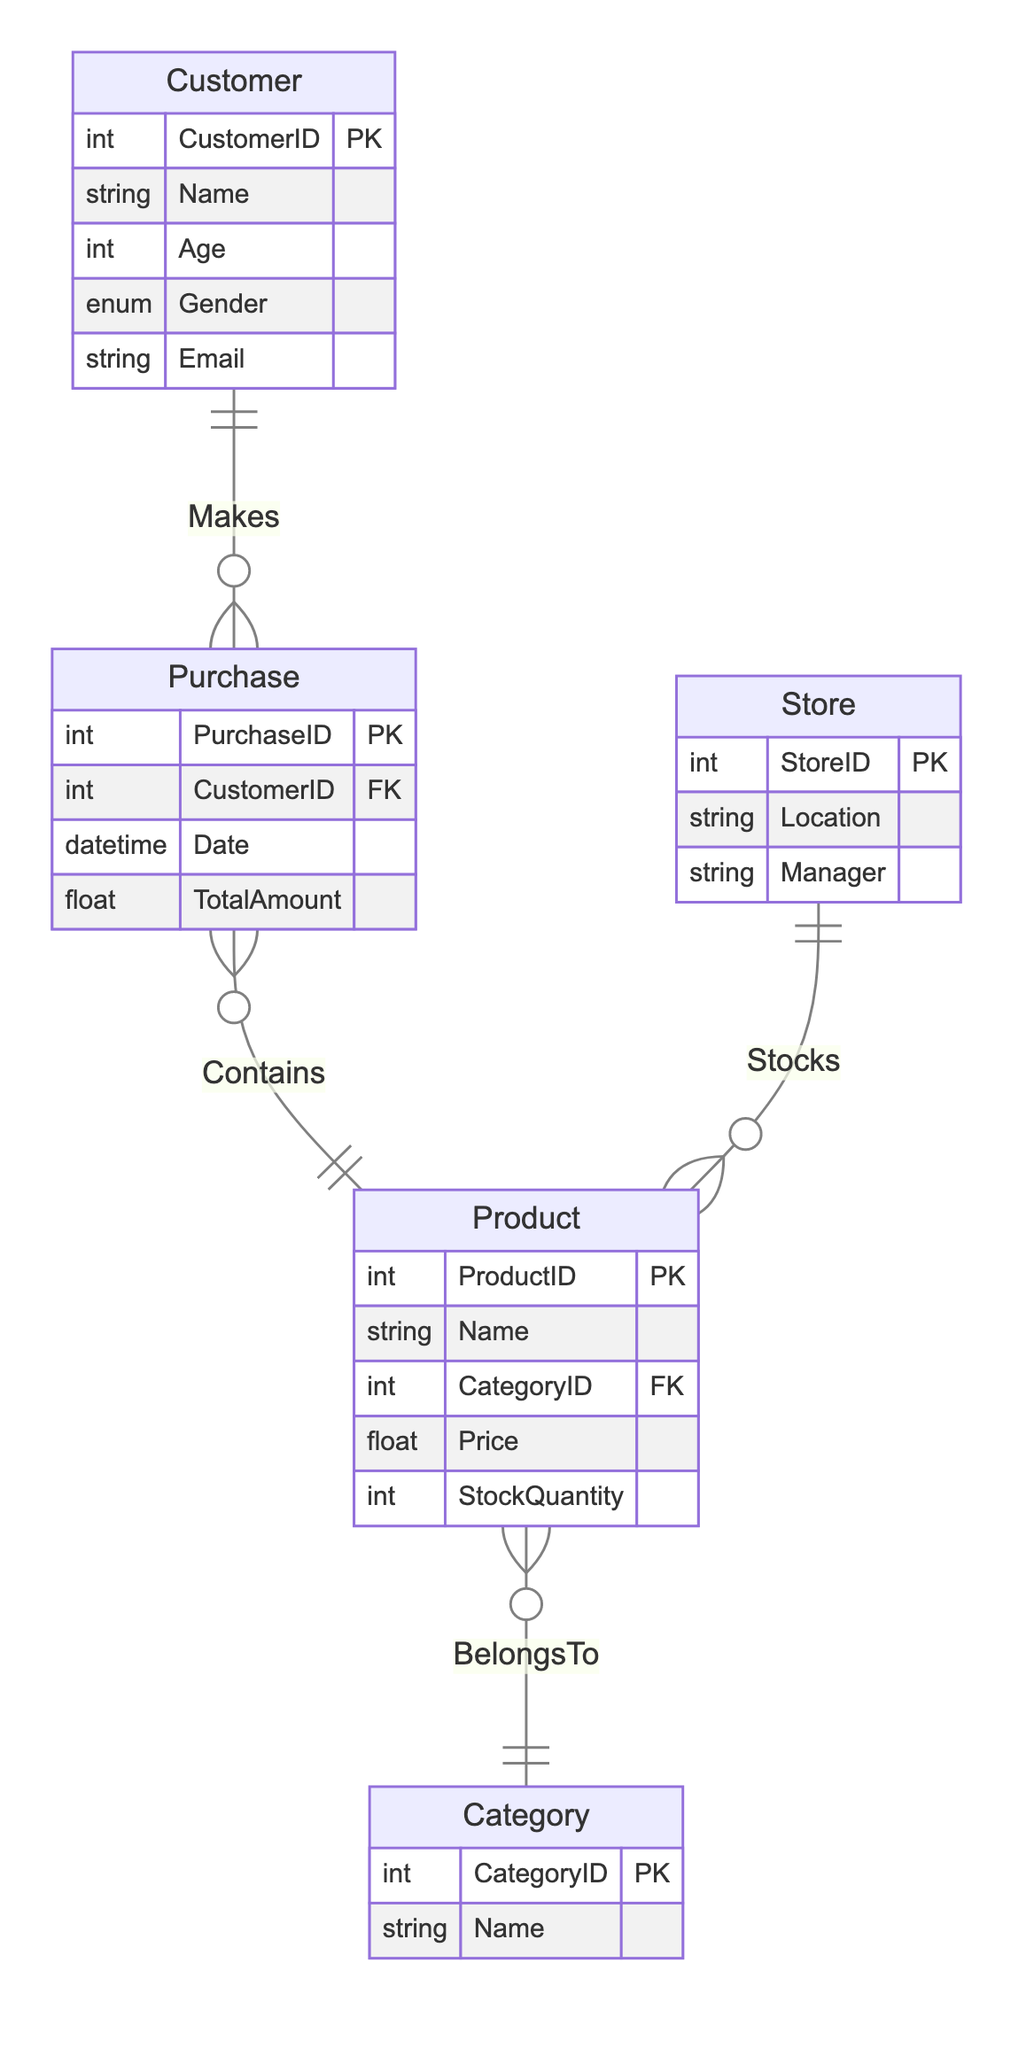What is the primary key for the Customer entity? The primary key for the Customer entity is identified in the diagram next to its attributes. It is labeled "CustomerID".
Answer: CustomerID How many total entities are represented in the diagram? By counting the entities shown in the diagram—Customer, Purchase, Product, Category, and Store—we determine there are five total entities.
Answer: Five What relationship exists between Product and Category? The diagram illustrates that each Product "BelongsTo" a Category, which indicates a one-to-many relationship where a Category can have multiple Products but each Product belongs to only one Category.
Answer: BelongsTo What attribute of Purchase indicates the total spending amount? The Purchase entity includes an attribute labeled "TotalAmount" that directly represents the total spending made by a customer on a purchase.
Answer: TotalAmount Which entity is related to the Store entity through the "Stocks" relationship? The diagram indicates that the Store entity has a "Stocks" relationship with the Product entity, meaning a Store holds inventory of Products.
Answer: Product How does the Customer interact with the Purchase entity? The diagram specifies that the Customer entity "Makes" a Purchase, signifying that each Purchase is associated with one specific Customer, creating a one-to-many relationship.
Answer: Makes What is the Foreign Key in the Purchase entity? The Purchase entity contains an attribute labeled "CustomerID", which acts as the Foreign Key linking it to the Customer entity to track which customer made the purchase.
Answer: CustomerID How many attributes does the Product entity have? By examining the attributes listed under the Product entity, we see it has five attributes: ProductID, Name, CategoryID, Price, and StockQuantity, totaling to five attributes.
Answer: Five What type of data does the Gender attribute in the Customer entity hold? The Gender attribute is defined as an "Enum" type in the diagram, which means it can take one of several predefined values: Male, Female, or Other.
Answer: Enum (Male, Female, Other) 